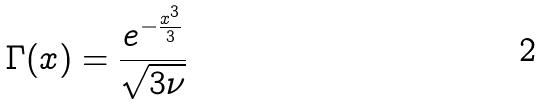Convert formula to latex. <formula><loc_0><loc_0><loc_500><loc_500>\Gamma ( x ) = \frac { e ^ { - \frac { x ^ { 3 } } { 3 } } } { \sqrt { 3 \nu } }</formula> 